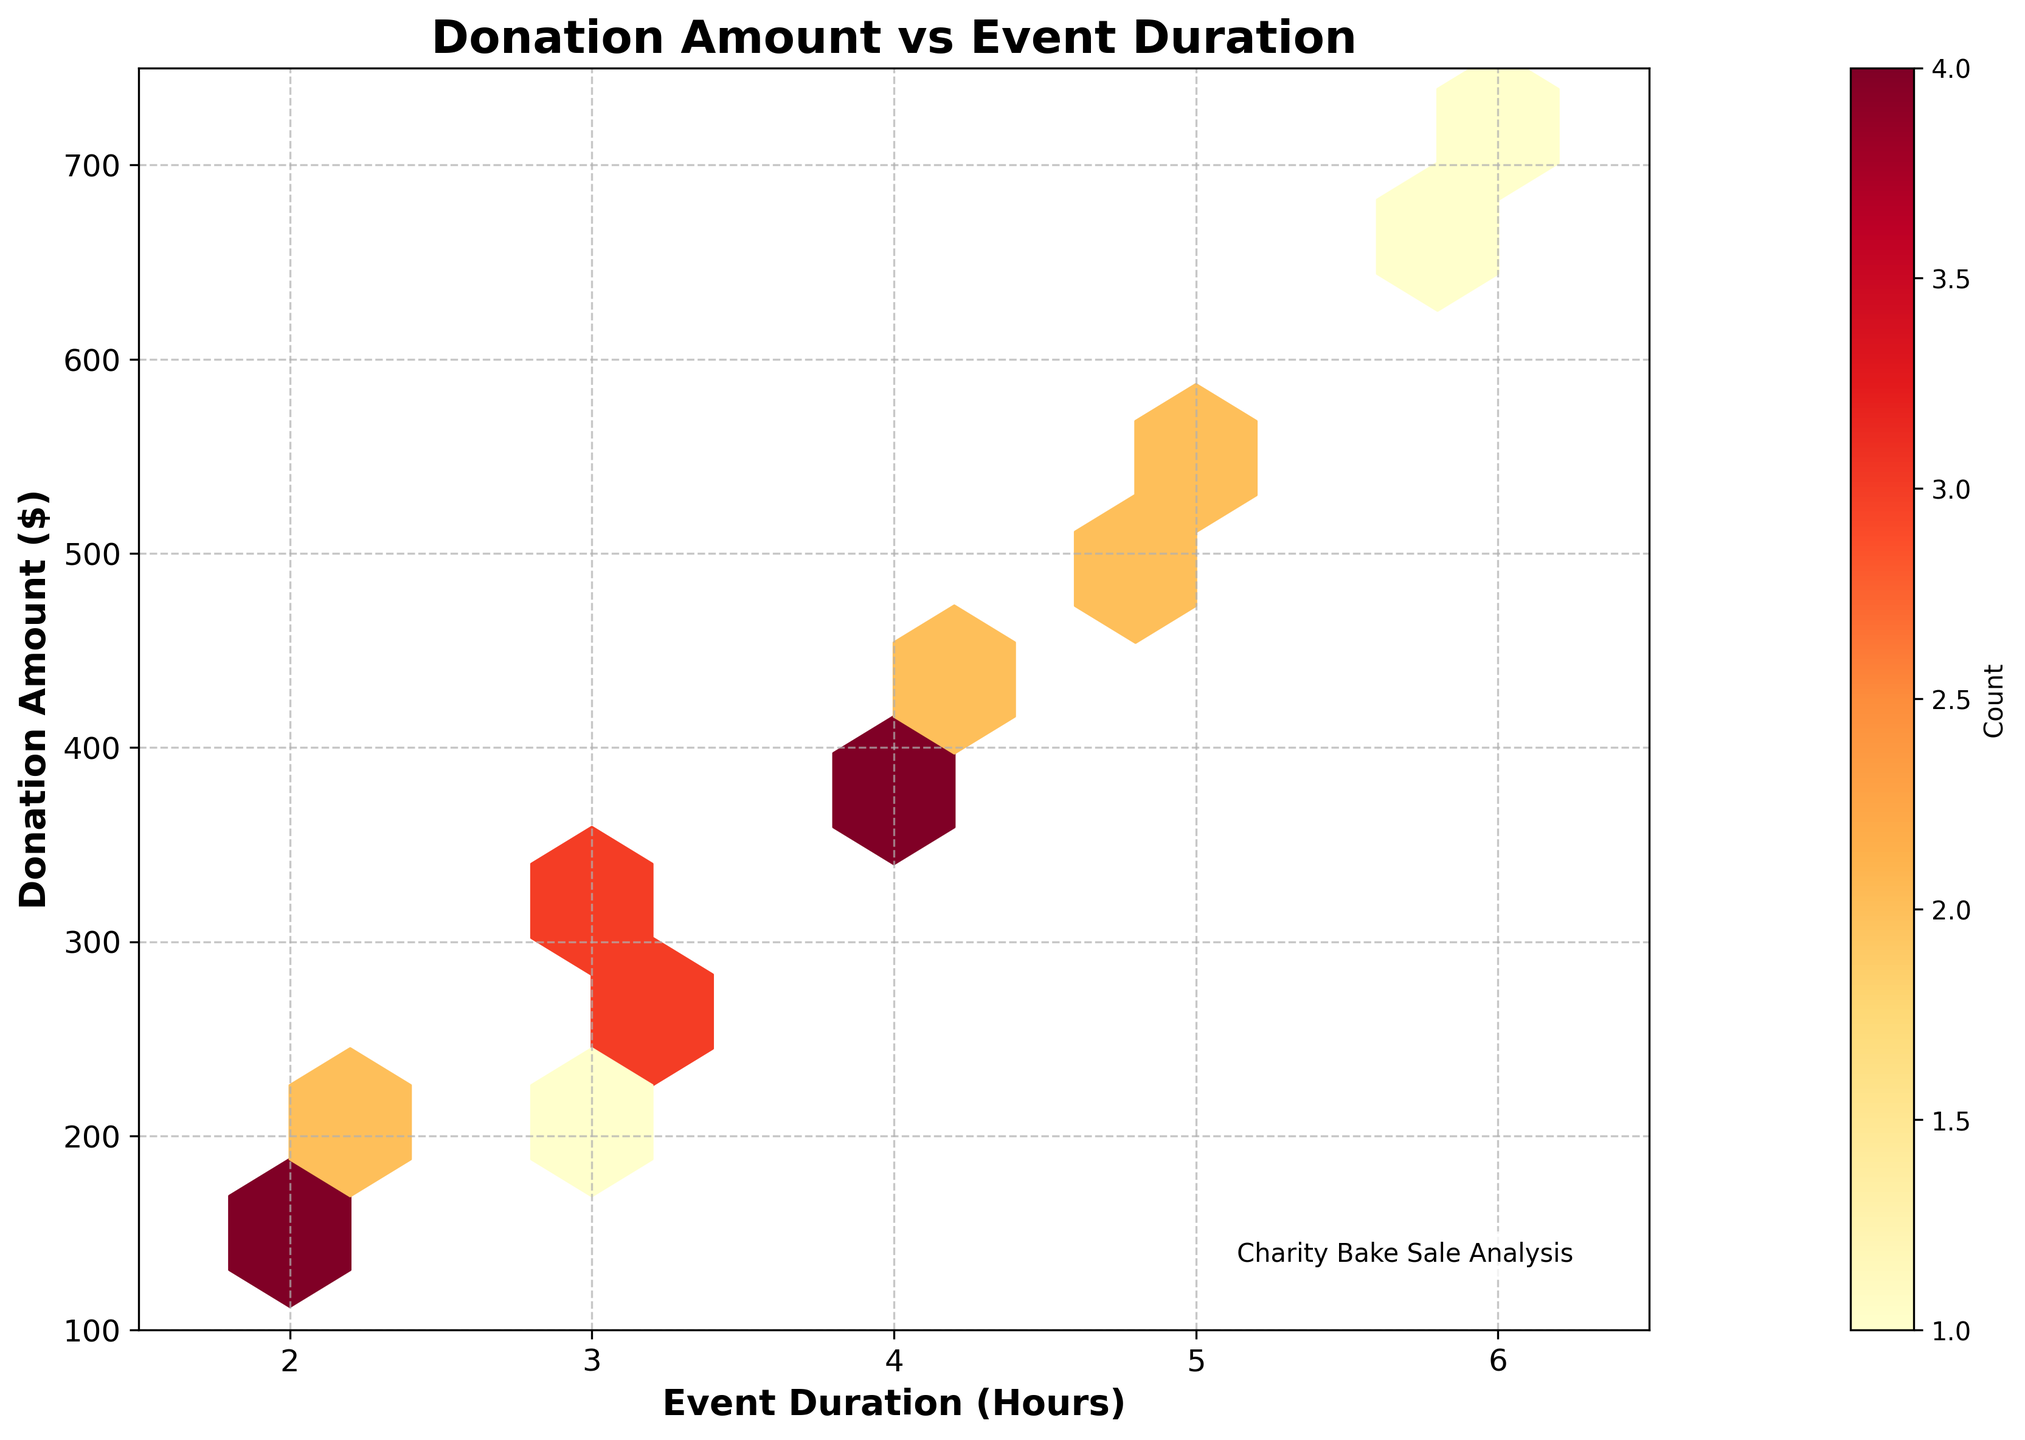What is the color scheme used in the hexbin plot? The hexbin plot uses a color scheme ranging from yellow to red (cmap='YlOrRd'). This means yellow represents areas with fewer counts, and red indicates higher counts within the hexagons.
Answer: Yellow to red What is the title of the hexbin plot? The title of the hexbin plot is displayed at the top center and it reads "Donation Amount vs Event Duration".
Answer: Donation Amount vs Event Duration What are the labels for the X and Y axes in the hexbin plot? The X-axis is labeled "Event Duration (Hours)" and the Y-axis is labeled "Donation Amount ($)". This helps in understanding the data being plotted against each other.
Answer: Event Duration (Hours), Donation Amount ($) How long is the event duration with the highest observed donation amount? The plot shows a maximum donation amount of $720. According to the data, this corresponds to an event duration of 6 hours, as shown by the hexagon with the highest donation amount.
Answer: 6 hours Which area has events that regularly receive donations in the range of $350 to $420? In the plot, hexagons representing donations between $350 and $420 are mainly clustered around event durations of 4 hours, which suggests many events lasting 4 hours receive donations in this range.
Answer: 4-hour events Is there any donation amount more common for events lasting exactly 3 hours? Yes, the plot shows that there are hexagons with higher counts around $270 to $310 for events lasting 3 hours, suggesting this is a more common donation range for such events.
Answer: $270 to $310 What is the range of event durations shown in the plot? The X-axis of the hexbin plot covers event durations ranging from just below 2 hours to just above 6 hours. The precise range is between 1.5 hours to 6.5 hours.
Answer: 1.5 to 6.5 hours At what event duration do we start seeing donations exceeding $500? Donations exceeding $500 are first visible at events with a duration of 5 hours or more, as seen by the hexagons in that region.
Answer: 5 hours What is the most frequently occurring range of donations for a 4-hour event? For 4-hour events, the hexagons with the highest count are around the $350-$430 range, indicating this is the most frequent donation range for these events.
Answer: $350-$430 How does the density of donations vary for events longer than 5 hours? For events longer than 5 hours, the hexagons gradually show higher donation amounts, with the most densely populated hexagon around the $680-$720 range. This indicates these events often receive higher donations.
Answer: Higher donations (up to $720) 